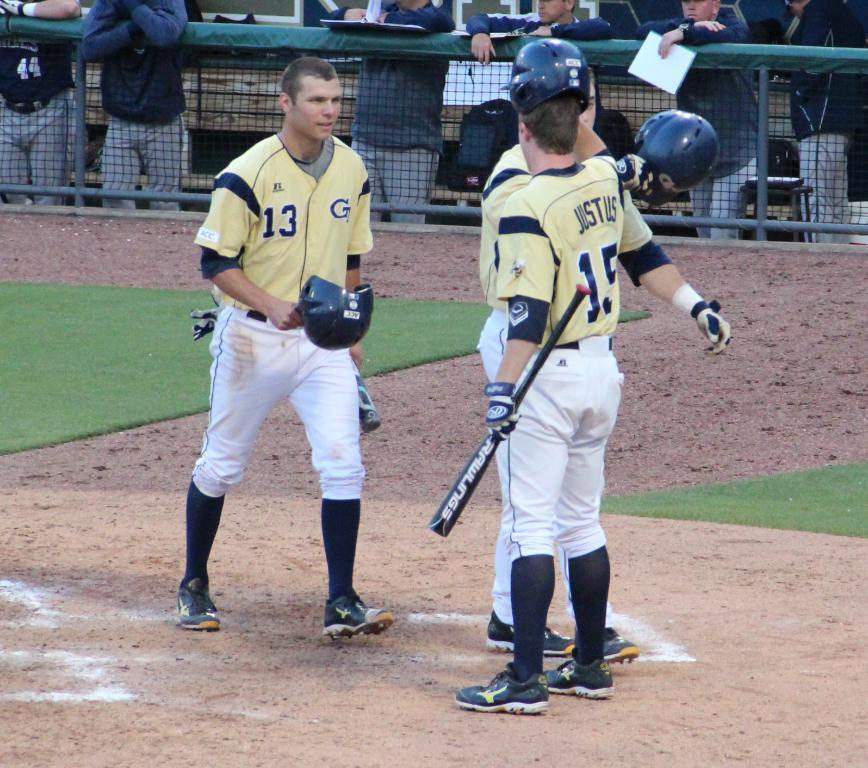<image>
Create a compact narrative representing the image presented. Player number 13 took their helmet off and is approaching player number 15. 